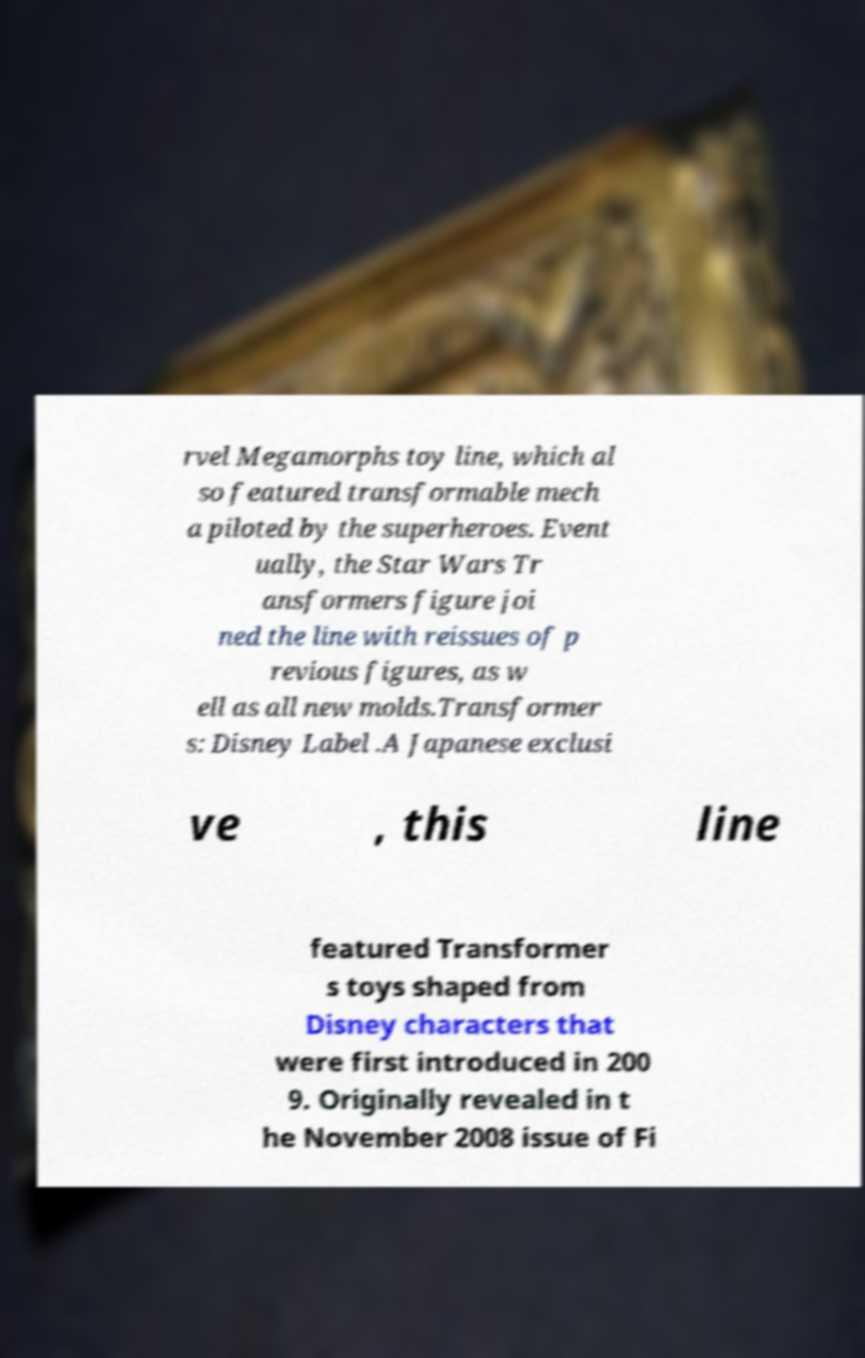There's text embedded in this image that I need extracted. Can you transcribe it verbatim? rvel Megamorphs toy line, which al so featured transformable mech a piloted by the superheroes. Event ually, the Star Wars Tr ansformers figure joi ned the line with reissues of p revious figures, as w ell as all new molds.Transformer s: Disney Label .A Japanese exclusi ve , this line featured Transformer s toys shaped from Disney characters that were first introduced in 200 9. Originally revealed in t he November 2008 issue of Fi 